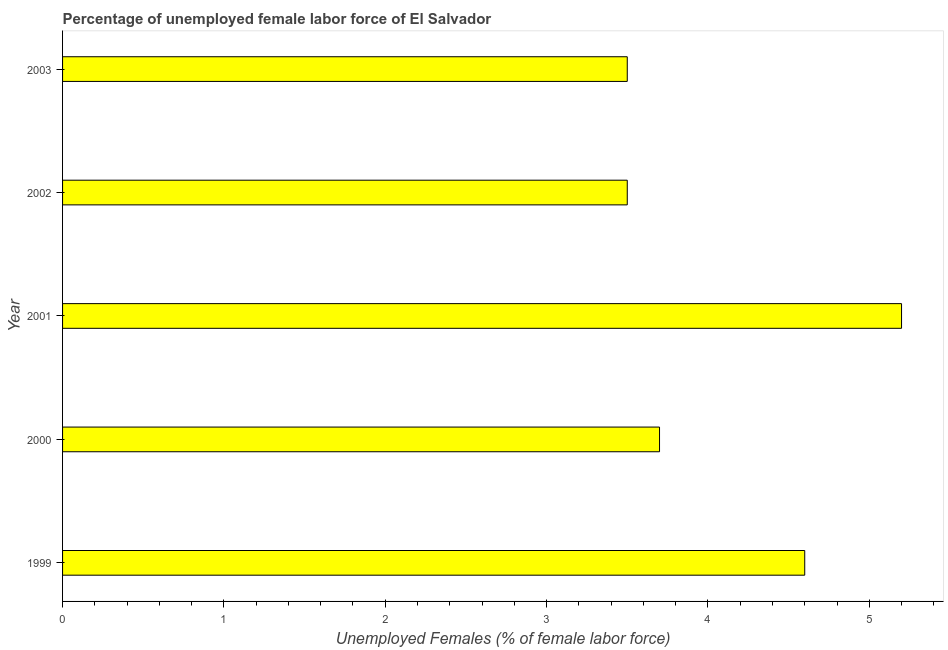Does the graph contain any zero values?
Your response must be concise. No. What is the title of the graph?
Make the answer very short. Percentage of unemployed female labor force of El Salvador. What is the label or title of the X-axis?
Offer a terse response. Unemployed Females (% of female labor force). What is the total unemployed female labour force in 2001?
Offer a very short reply. 5.2. Across all years, what is the maximum total unemployed female labour force?
Make the answer very short. 5.2. Across all years, what is the minimum total unemployed female labour force?
Keep it short and to the point. 3.5. What is the sum of the total unemployed female labour force?
Your answer should be compact. 20.5. What is the difference between the total unemployed female labour force in 2000 and 2001?
Your answer should be compact. -1.5. What is the average total unemployed female labour force per year?
Ensure brevity in your answer.  4.1. What is the median total unemployed female labour force?
Keep it short and to the point. 3.7. In how many years, is the total unemployed female labour force greater than 0.2 %?
Provide a short and direct response. 5. What is the ratio of the total unemployed female labour force in 2001 to that in 2003?
Ensure brevity in your answer.  1.49. Is the difference between the total unemployed female labour force in 2000 and 2002 greater than the difference between any two years?
Make the answer very short. No. What is the difference between the highest and the second highest total unemployed female labour force?
Keep it short and to the point. 0.6. What is the difference between the highest and the lowest total unemployed female labour force?
Your response must be concise. 1.7. In how many years, is the total unemployed female labour force greater than the average total unemployed female labour force taken over all years?
Provide a succinct answer. 2. How many bars are there?
Your response must be concise. 5. How many years are there in the graph?
Give a very brief answer. 5. What is the difference between two consecutive major ticks on the X-axis?
Your answer should be very brief. 1. Are the values on the major ticks of X-axis written in scientific E-notation?
Ensure brevity in your answer.  No. What is the Unemployed Females (% of female labor force) in 1999?
Offer a very short reply. 4.6. What is the Unemployed Females (% of female labor force) in 2000?
Your response must be concise. 3.7. What is the Unemployed Females (% of female labor force) of 2001?
Provide a short and direct response. 5.2. What is the Unemployed Females (% of female labor force) of 2002?
Provide a short and direct response. 3.5. What is the Unemployed Females (% of female labor force) of 2003?
Keep it short and to the point. 3.5. What is the difference between the Unemployed Females (% of female labor force) in 1999 and 2000?
Your response must be concise. 0.9. What is the difference between the Unemployed Females (% of female labor force) in 1999 and 2001?
Your response must be concise. -0.6. What is the difference between the Unemployed Females (% of female labor force) in 2000 and 2001?
Keep it short and to the point. -1.5. What is the difference between the Unemployed Females (% of female labor force) in 2000 and 2003?
Keep it short and to the point. 0.2. What is the difference between the Unemployed Females (% of female labor force) in 2002 and 2003?
Make the answer very short. 0. What is the ratio of the Unemployed Females (% of female labor force) in 1999 to that in 2000?
Your answer should be very brief. 1.24. What is the ratio of the Unemployed Females (% of female labor force) in 1999 to that in 2001?
Provide a succinct answer. 0.89. What is the ratio of the Unemployed Females (% of female labor force) in 1999 to that in 2002?
Offer a terse response. 1.31. What is the ratio of the Unemployed Females (% of female labor force) in 1999 to that in 2003?
Your answer should be very brief. 1.31. What is the ratio of the Unemployed Females (% of female labor force) in 2000 to that in 2001?
Your answer should be very brief. 0.71. What is the ratio of the Unemployed Females (% of female labor force) in 2000 to that in 2002?
Give a very brief answer. 1.06. What is the ratio of the Unemployed Females (% of female labor force) in 2000 to that in 2003?
Your answer should be compact. 1.06. What is the ratio of the Unemployed Females (% of female labor force) in 2001 to that in 2002?
Provide a succinct answer. 1.49. What is the ratio of the Unemployed Females (% of female labor force) in 2001 to that in 2003?
Offer a very short reply. 1.49. 